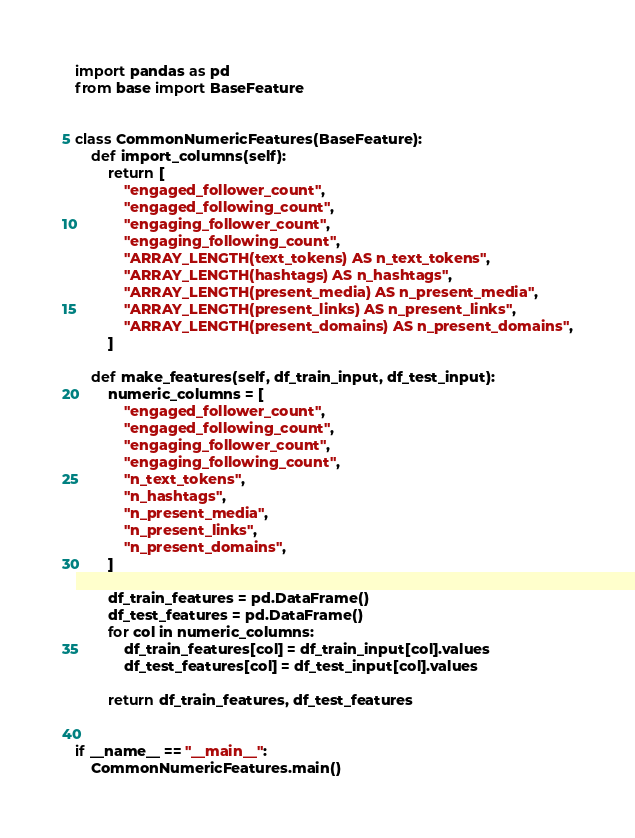<code> <loc_0><loc_0><loc_500><loc_500><_Python_>import pandas as pd
from base import BaseFeature


class CommonNumericFeatures(BaseFeature):
    def import_columns(self):
        return [
            "engaged_follower_count",
            "engaged_following_count",
            "engaging_follower_count",
            "engaging_following_count",
            "ARRAY_LENGTH(text_tokens) AS n_text_tokens",
            "ARRAY_LENGTH(hashtags) AS n_hashtags",
            "ARRAY_LENGTH(present_media) AS n_present_media",
            "ARRAY_LENGTH(present_links) AS n_present_links",
            "ARRAY_LENGTH(present_domains) AS n_present_domains",
        ]

    def make_features(self, df_train_input, df_test_input):
        numeric_columns = [
            "engaged_follower_count",
            "engaged_following_count",
            "engaging_follower_count",
            "engaging_following_count",
            "n_text_tokens",
            "n_hashtags",
            "n_present_media",
            "n_present_links",
            "n_present_domains",
        ]

        df_train_features = pd.DataFrame()
        df_test_features = pd.DataFrame()
        for col in numeric_columns:
            df_train_features[col] = df_train_input[col].values
            df_test_features[col] = df_test_input[col].values

        return df_train_features, df_test_features


if __name__ == "__main__":
    CommonNumericFeatures.main()
</code> 